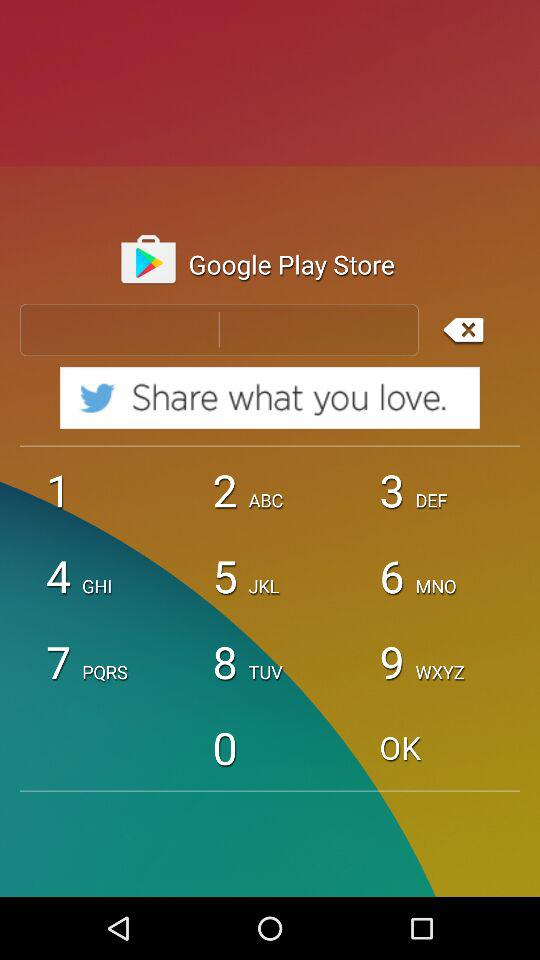What is the version number? The version number is v.7.5.0. 